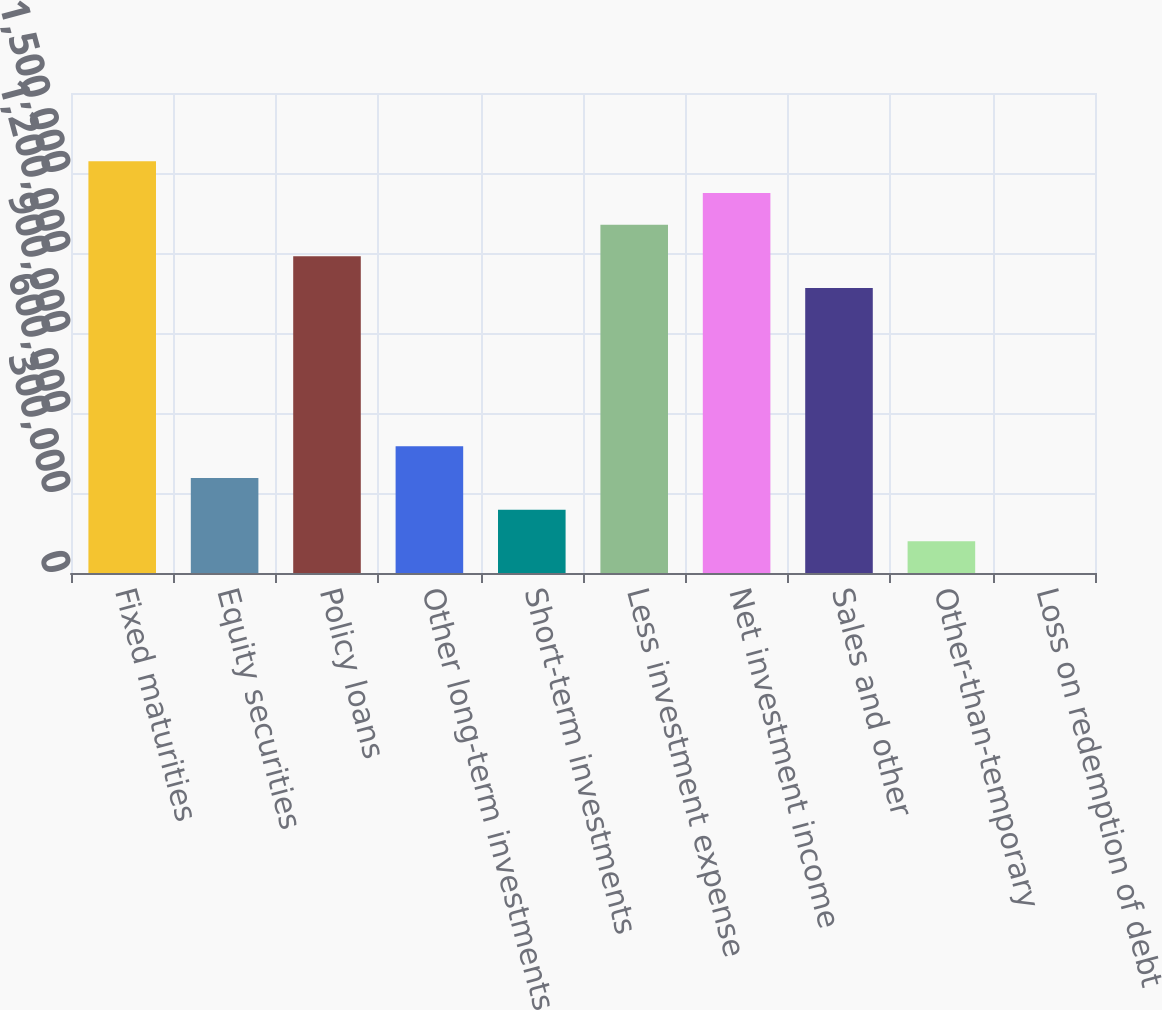Convert chart to OTSL. <chart><loc_0><loc_0><loc_500><loc_500><bar_chart><fcel>Fixed maturities<fcel>Equity securities<fcel>Policy loans<fcel>Other long-term investments<fcel>Short-term investments<fcel>Less investment expense<fcel>Net investment income<fcel>Sales and other<fcel>Other-than-temporary<fcel>Loss on redemption of debt<nl><fcel>1.54379e+06<fcel>356259<fcel>1.18753e+06<fcel>475012<fcel>237506<fcel>1.30628e+06<fcel>1.42503e+06<fcel>1.06878e+06<fcel>118753<fcel>0.24<nl></chart> 